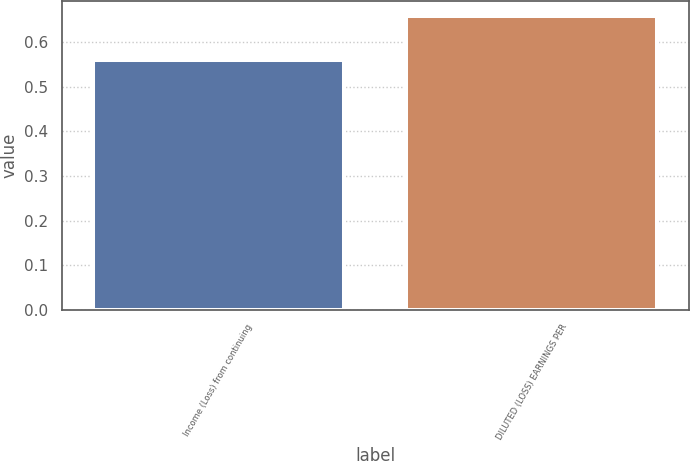<chart> <loc_0><loc_0><loc_500><loc_500><bar_chart><fcel>Income (Loss) from continuing<fcel>DILUTED (LOSS) EARNINGS PER<nl><fcel>0.56<fcel>0.66<nl></chart> 